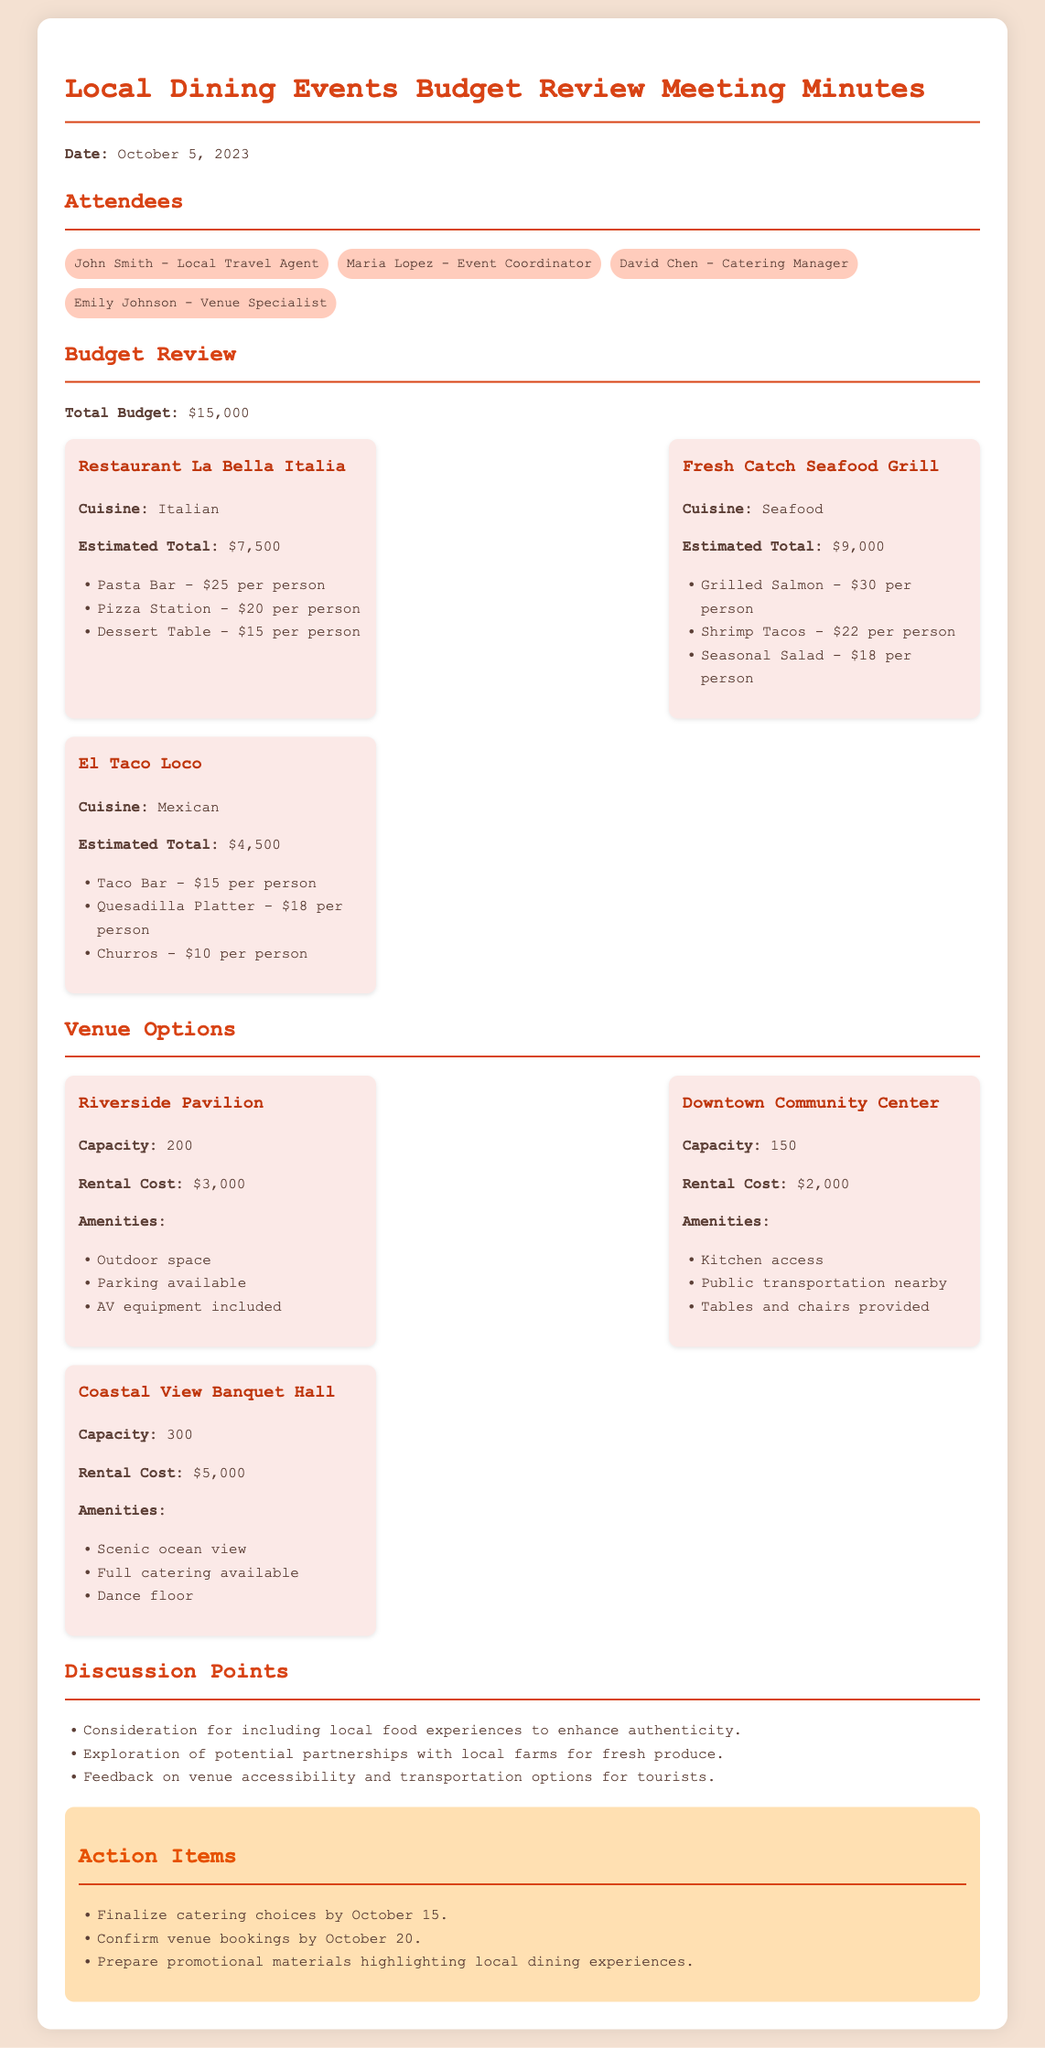What is the total budget for the dining events? The total budget is stated clearly in the document as $15,000.
Answer: $15,000 What is the estimated total cost for Fresh Catch Seafood Grill? The estimated total cost for Fresh Catch Seafood Grill is detailed in the document.
Answer: $9,000 How many attendees can the Coastal View Banquet Hall accommodate? The document specifies the capacity of Coastal View Banquet Hall.
Answer: 300 What is the rental cost for Downtown Community Center? The rental cost is explicitly mentioned in the document for Downtown Community Center.
Answer: $2,000 What action needs to be completed by October 15? The action items section lists finalizing catering choices as due by October 15.
Answer: Finalize catering choices Which venue has outdoor space available? The amenities section notes that Riverside Pavilion includes outdoor space.
Answer: Riverside Pavilion How much does the Pasta Bar cost per person? The cost per person for the Pasta Bar is provided in the budget review for La Bella Italia.
Answer: $25 per person What should be prepared to promote local dining experiences? The document outlines action items that include preparing promotional materials for local dining.
Answer: Promotional materials Which cuisine is offered at El Taco Loco? The cuisine type for El Taco Loco is specified in the budget review section.
Answer: Mexican 